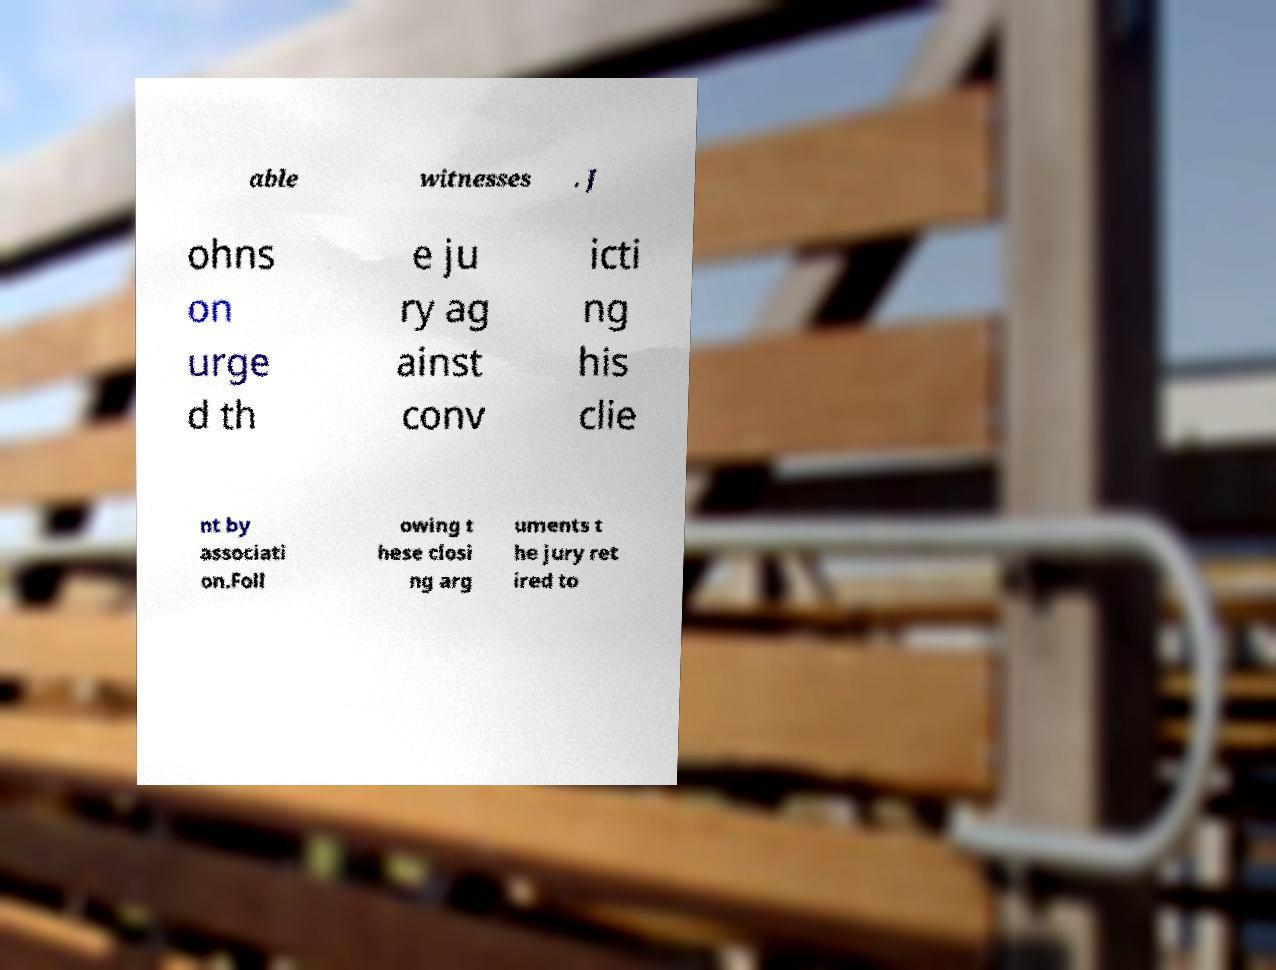Can you accurately transcribe the text from the provided image for me? able witnesses . J ohns on urge d th e ju ry ag ainst conv icti ng his clie nt by associati on.Foll owing t hese closi ng arg uments t he jury ret ired to 